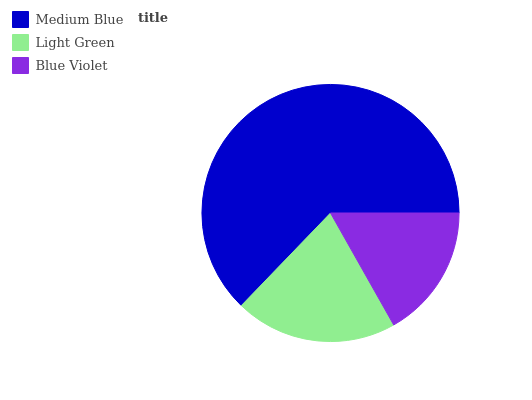Is Blue Violet the minimum?
Answer yes or no. Yes. Is Medium Blue the maximum?
Answer yes or no. Yes. Is Light Green the minimum?
Answer yes or no. No. Is Light Green the maximum?
Answer yes or no. No. Is Medium Blue greater than Light Green?
Answer yes or no. Yes. Is Light Green less than Medium Blue?
Answer yes or no. Yes. Is Light Green greater than Medium Blue?
Answer yes or no. No. Is Medium Blue less than Light Green?
Answer yes or no. No. Is Light Green the high median?
Answer yes or no. Yes. Is Light Green the low median?
Answer yes or no. Yes. Is Medium Blue the high median?
Answer yes or no. No. Is Blue Violet the low median?
Answer yes or no. No. 